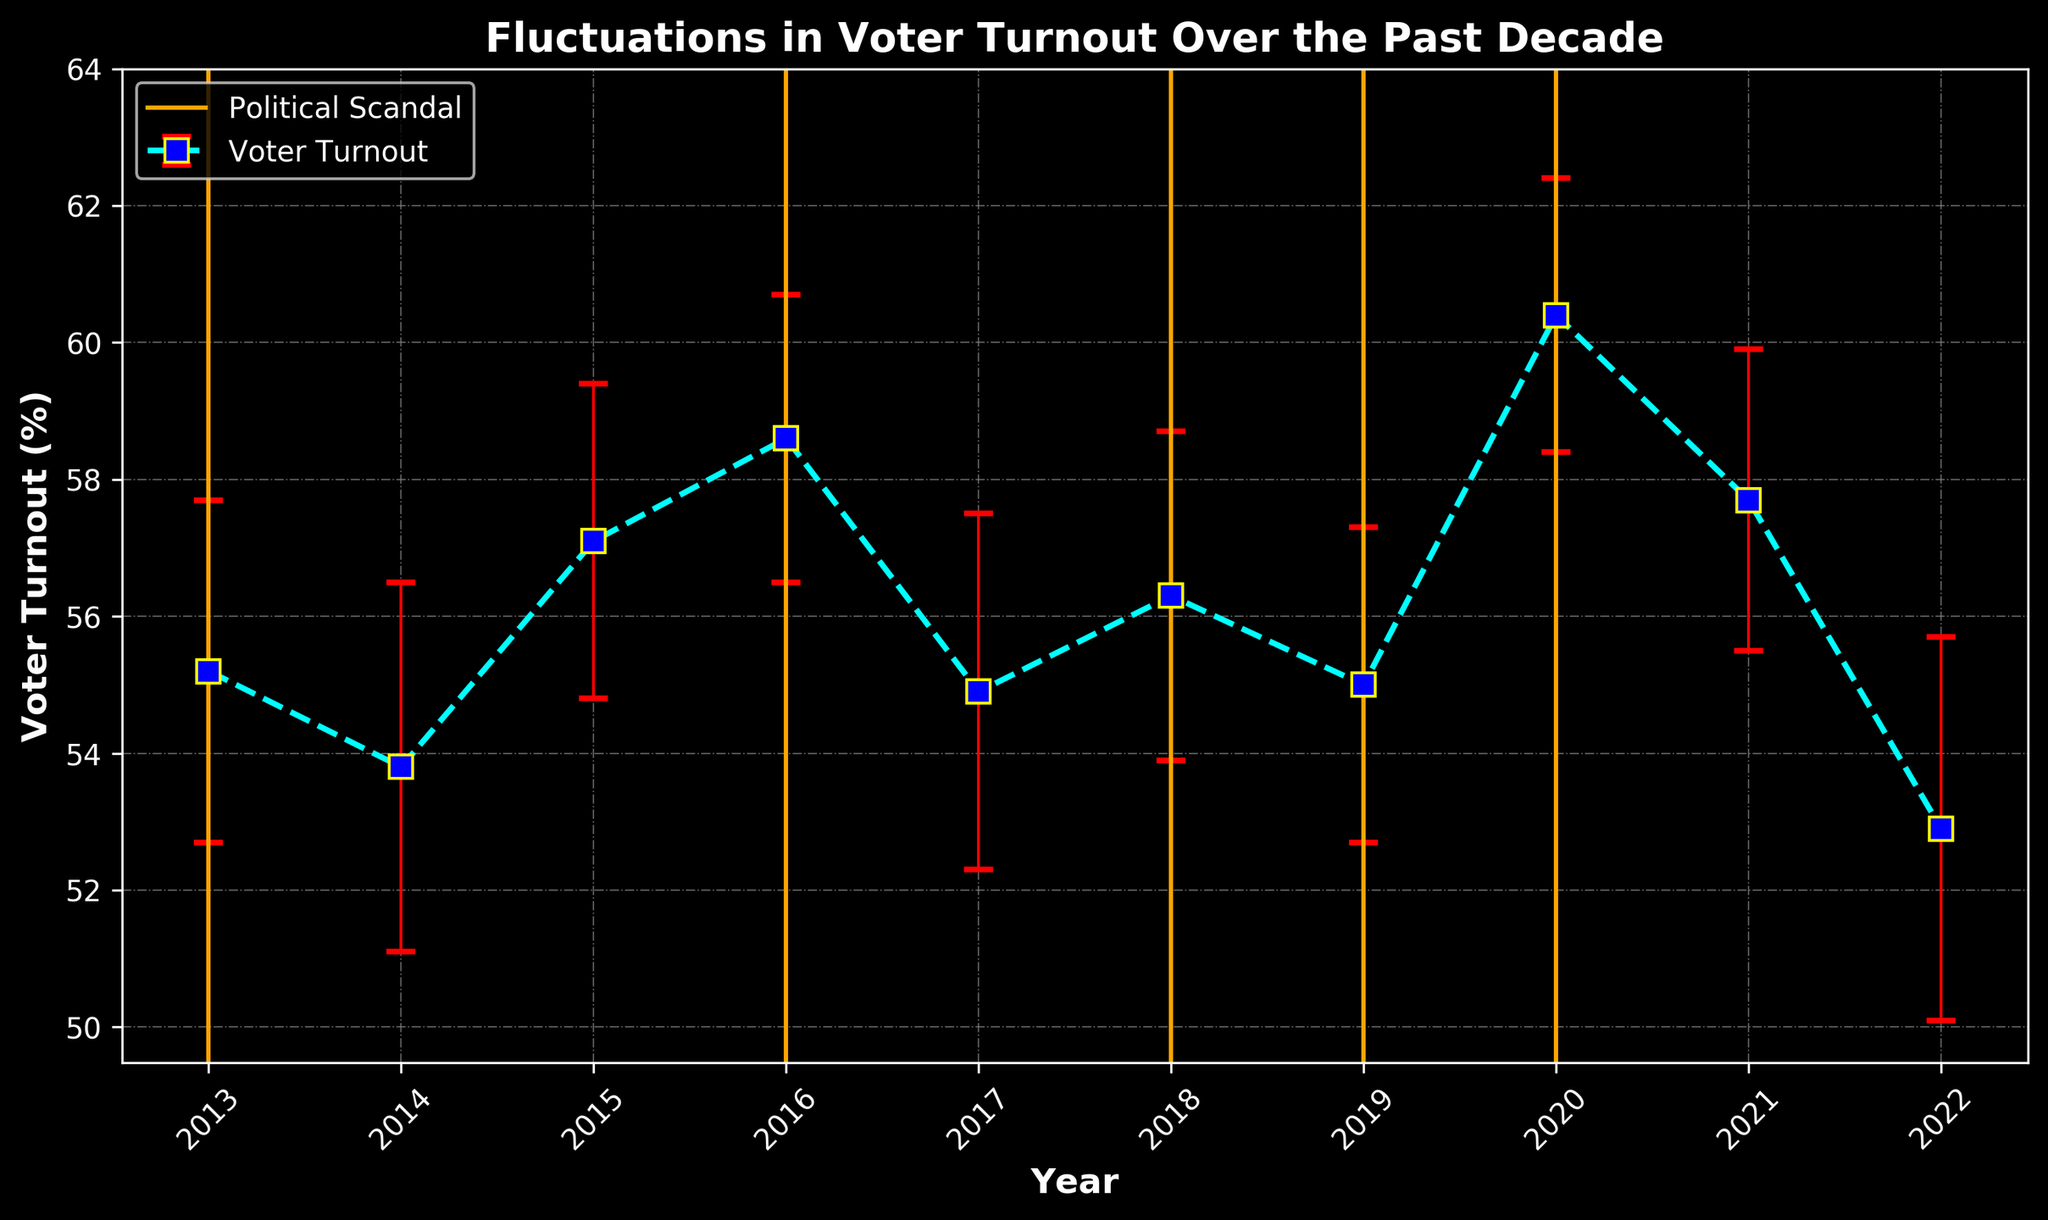What year had the highest voter turnout? The plot shows voter turnout percentages on the Y-axis and years on the X-axis. By scanning the graph, we can see where the voter turnout percentage peaks. The highest voter turnout was in 2020.
Answer: 2020 How many years witnessed a political scandal? The orange vertical lines in the graph denote years with political scandals. Counting these lines gives the total number of years with scandals. There are 5 years with political scandals.
Answer: 5 What is the average voter turnout during years with no political scandal? To find the average voter turnout during non-scandal years (2014, 2015, 2017, 2021, 2022), sum their voter turnout percentages and then divide by the number of these years (5): (53.8 + 57.1 + 54.9 + 57.7 + 52.9) / 5 = 275.4 / 5 = 55.08.
Answer: 55.08 Which had a greater impact on voter turnout in terms of increase, the scandal years or the non-scandal years? Calculate the difference in average voter turnout between scandal years and non-scandal years. The average for scandal years (2013, 2016, 2018, 2019, 2020) is (55.2 + 58.6 + 56.3 + 55.0 + 60.4) / 5 = 285.5 / 5 = 57.1. The average for non-scandal years (53.8, 57.1, 54.9, 57.7, 52.9) is 55.08. Compare the two averages: 57.1 (scandal) is greater than 55.08 (non-scandal), indicating scandal years show higher voter turnout.
Answer: Scandal years What was the voter turnout in 2013 and how does it compare to that in 2016? Locate the specific years on the X-axis and compare their voter turnout values on the Y-axis. The voter turnout in 2013 was 55.2, and in 2016 it was 58.6. Thus, comparing the two: 58.6 is higher than 55.2, meaning voter turnout increased from 2013 to 2016.
Answer: 58.6 is higher Which year had the largest standard deviation in voter turnout? Look for the error bars (red) representing standard deviation. The year with the largest error bar corresponds to the year with the highest standard deviation. 2022, with a standard deviation of 2.8, had the largest one.
Answer: 2022 How did voter turnout change from 2017 to 2018? Check the voter turnout values for both years. In 2017, it was 54.9, and in 2018, it was 56.3, representing an increase. Thus, voter turnout increased by 1.4 from 2017 to 2018.
Answer: Increased by 1.4 What is the overall trend of voter turnout over the decade despite fluctuations? Analyzing the error bars and the overall line connecting voter turnout points, it can be seen that the general trend is upward, starting at 55.2 in 2013 and peaking at 60.4 in 2020, even with some intermediate drops. This indicates an increasing trend throughout the decade.
Answer: Increasing trend 